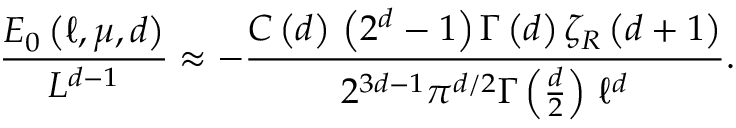Convert formula to latex. <formula><loc_0><loc_0><loc_500><loc_500>\frac { E _ { 0 } \left ( \ell , \mu , d \right ) } { L ^ { d - 1 } } \approx - \frac { C \left ( d \right ) \, \left ( 2 ^ { d } - 1 \right ) \Gamma \left ( d \right ) \zeta _ { R } \left ( d + 1 \right ) } { 2 ^ { 3 d - 1 } \pi ^ { d / 2 } \Gamma \left ( \frac { d } { 2 } \right ) \, \ell ^ { d } } .</formula> 